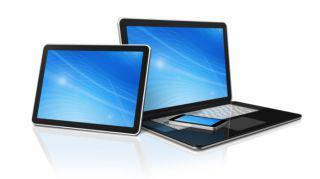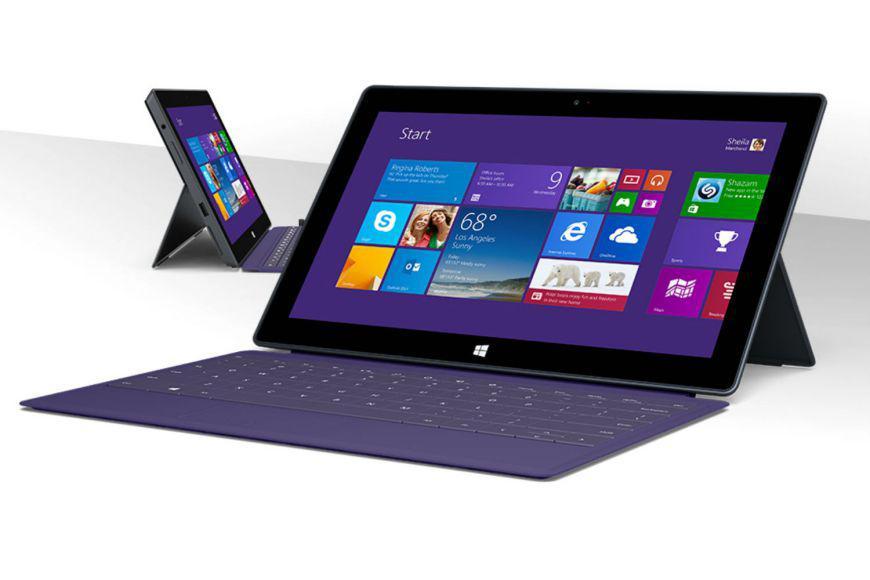The first image is the image on the left, the second image is the image on the right. Analyze the images presented: Is the assertion "There are more than two computers in total." valid? Answer yes or no. Yes. 